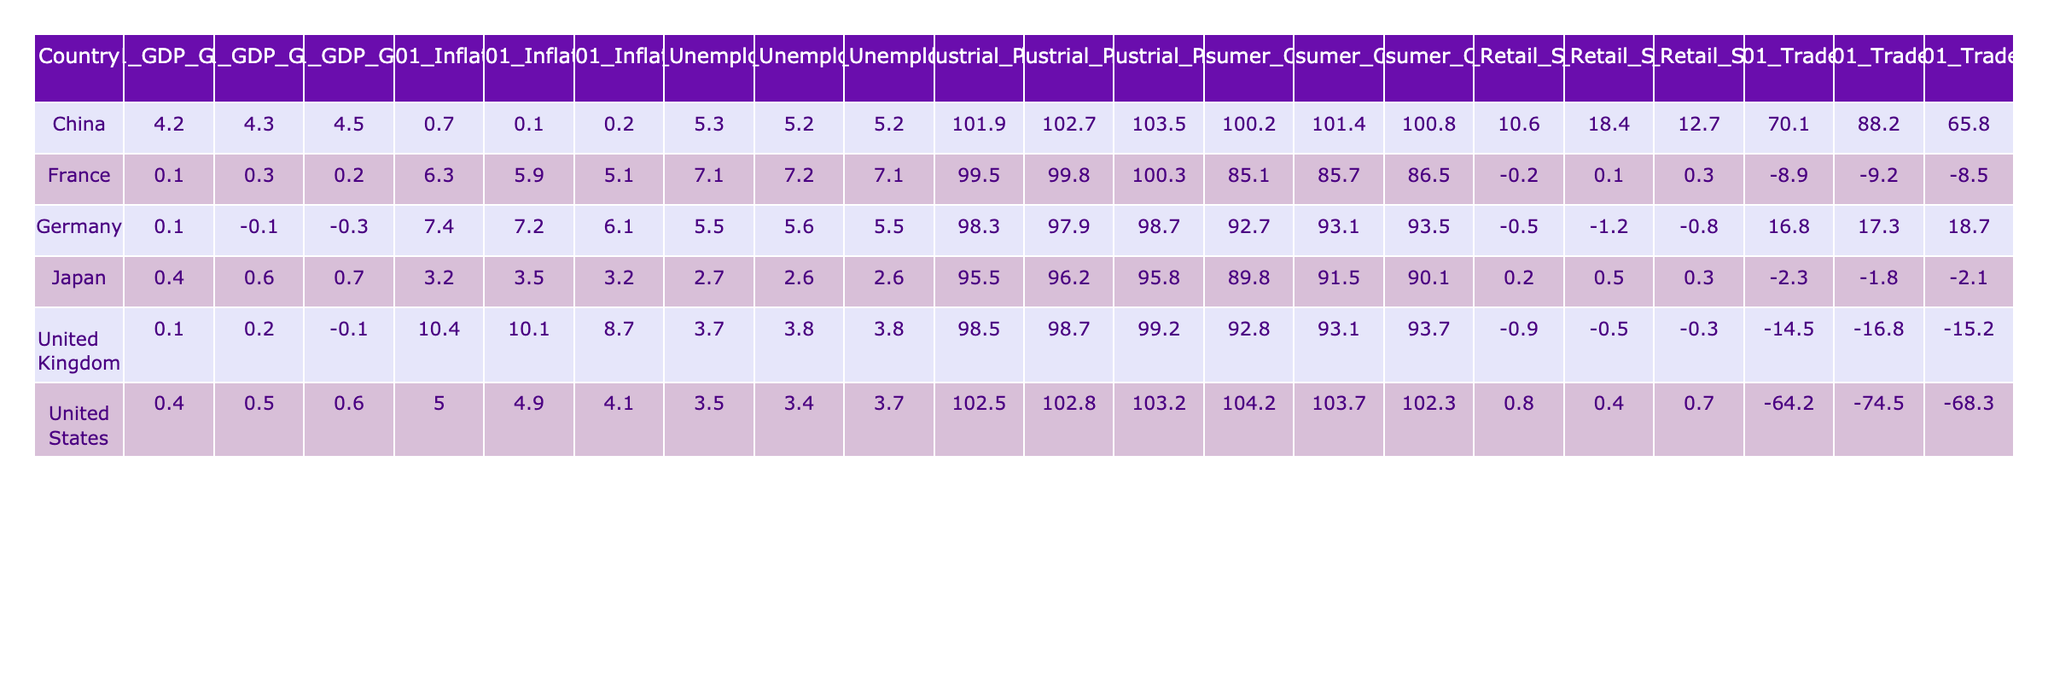What is the GDP Growth Rate of China in May 2023? Looking at the row for China under the column for May 2023, the GDP Growth Rate is listed as 4.5.
Answer: 4.5 What is the highest Inflation Rate recorded among the countries for April 2023? The Inflation Rates for April 2023 are 4.9 (United States), 7.2 (Germany), 3.5 (Japan), 0.1 (China), 10.1 (United Kingdom), and 5.9 (France). The highest is 10.1 for the United Kingdom.
Answer: 10.1 Which country has the lowest Unemployment Rate in May 2023? The Unemployment Rates for May 2023 are 3.7 (United States), 5.5 (Germany), 2.6 (Japan), 5.2 (China), 3.8 (United Kingdom), and 7.1 (France). The lowest is 2.6 for Japan.
Answer: Japan What is the average Retail Sales Growth for the United States over the three months? The Retail Sales Growth values for the United States are 0.7 (May), 0.4 (April), and 0.8 (March). The average is calculated as (0.7 + 0.4 + 0.8) / 3 = 0.6333.
Answer: 0.63 Did any country have a negative GDP Growth Rate in April 2023? The GDP Growth Rates for April 2023 are 0.5 (United States), -0.1 (Germany), 0.6 (Japan), 4.3 (China), 0.2 (United Kingdom), and 0.3 (France). Germany had a negative GDP Growth Rate, thus confirming the statement.
Answer: Yes What is the difference in Trade Balance between China and the United States in May 2023? The Trade Balance for China in May 2023 is 65.8 and for the United States it is -68.3. The difference is 65.8 - (-68.3) = 65.8 + 68.3 = 134.1.
Answer: 134.1 Which country saw the largest decline in Industrial Production Index from March 2023 to May 2023? The Industrial Production Index values for May 2023 are 103.2 (United States), 98.7 (Germany), 95.8 (Japan), 103.5 (China), 99.2 (United Kingdom), and 100.3 (France). For March 2023, the values are 102.5 (United States), 98.3 (Germany), 95.5 (Japan), 101.9 (China), 98.5 (United Kingdom), and 99.5 (France). The declines are calculated as follows: US = 103.2 - 102.5 = 0.7, Germany = 98.7 - 98.3 = 0.4, Japan = 95.8 - 95.5 = 0.3, China = 103.5 - 101.9 = 1.6, UK = 99.2 - 98.5 = 0.7, France = 100.3 - 99.5 = 0.8. The largest decline is for China with a decrease of 1.6.
Answer: China What is the median Unemployment Rate across all countries for March 2023? The Unemployment Rates for March 2023 are 3.5 (United States), 5.5 (Germany), 2.7 (Japan), 5.3 (China), 3.7 (United Kingdom), and 7.1 (France). Arranging these in order: 2.7, 3.5, 3.7, 5.3, 5.5, 7.1. The median is the average of the two middle numbers: (3.7 + 5.3) / 2 = 4.5.
Answer: 4.5 Is the Consumer Confidence Index higher in Japan than in Germany for April 2023? The Consumer Confidence Index values for April 2023 are 103.7 (United States), 93.1 (Germany), 91.5 (Japan), 101.4 (China), 93.1 (United Kingdom), and 85.7 (France). Comparing Germany (93.1) and Japan (91.5), Japan's index is lower than Germany's; therefore, the statement is false.
Answer: No What was the change in Inflation Rate from March 2023 to May 2023 for the United Kingdom? The Inflation Rates for the United Kingdom are 10.4 (March), 10.1 (April), and 8.7 (May). The change from March to May is 8.7 - 10.4 = -1.7, indicating a decrease.
Answer: -1.7 